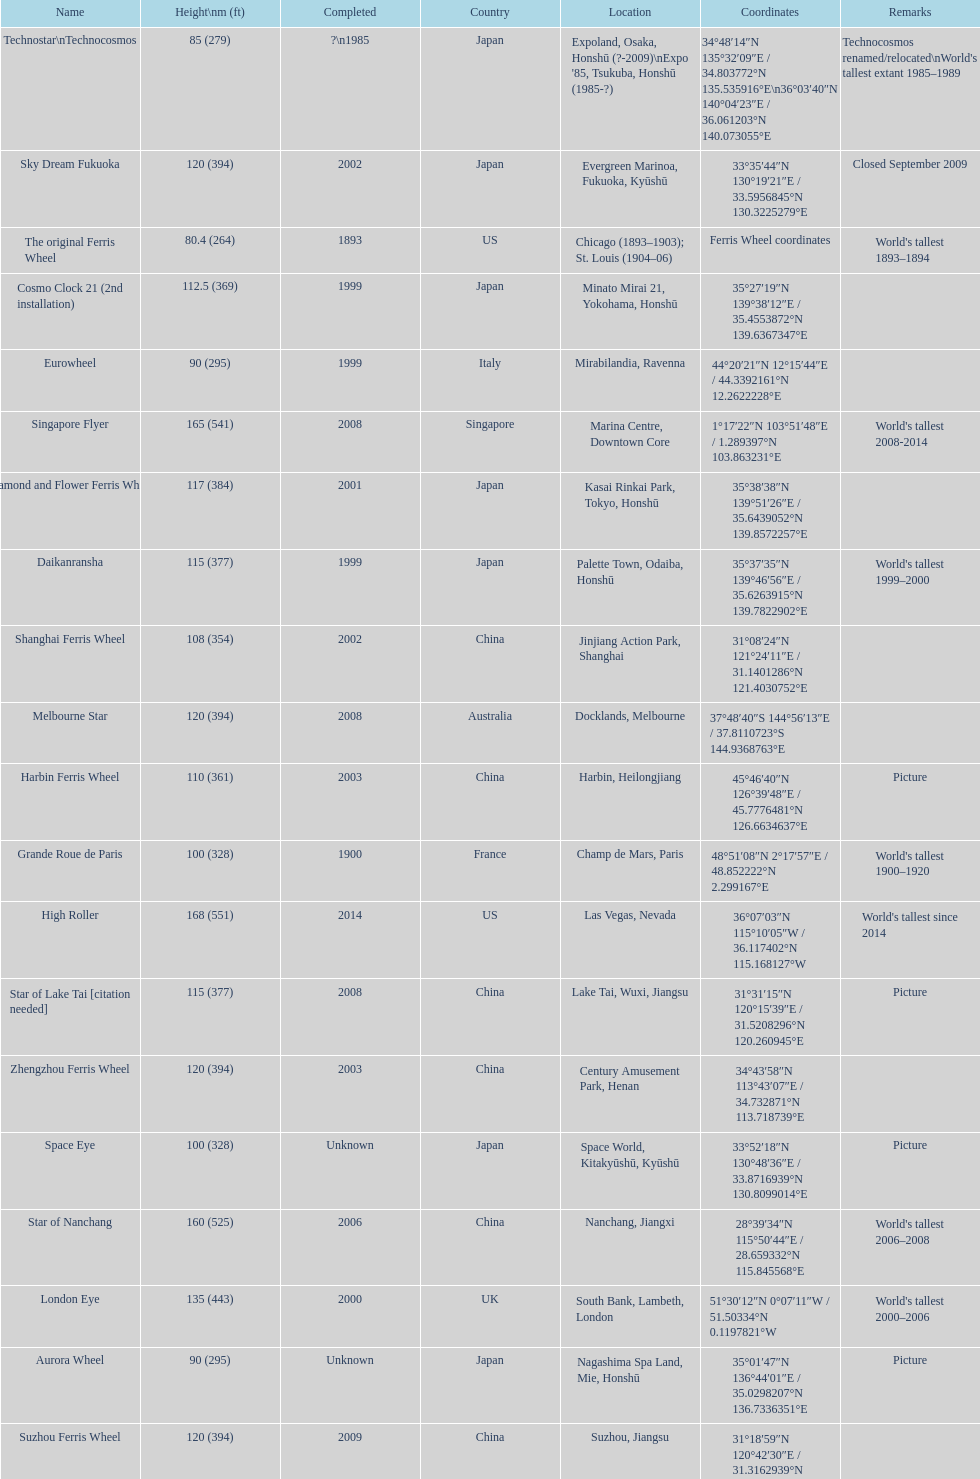Which of the following roller coasters is the oldest: star of lake tai, star of nanchang, melbourne star Star of Nanchang. 